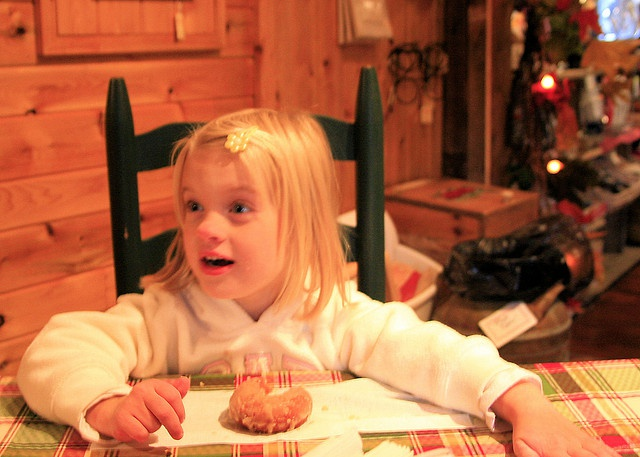Describe the objects in this image and their specific colors. I can see people in brown, orange, khaki, salmon, and red tones, dining table in brown, khaki, orange, and salmon tones, chair in brown, black, red, and maroon tones, and donut in brown, orange, red, salmon, and khaki tones in this image. 